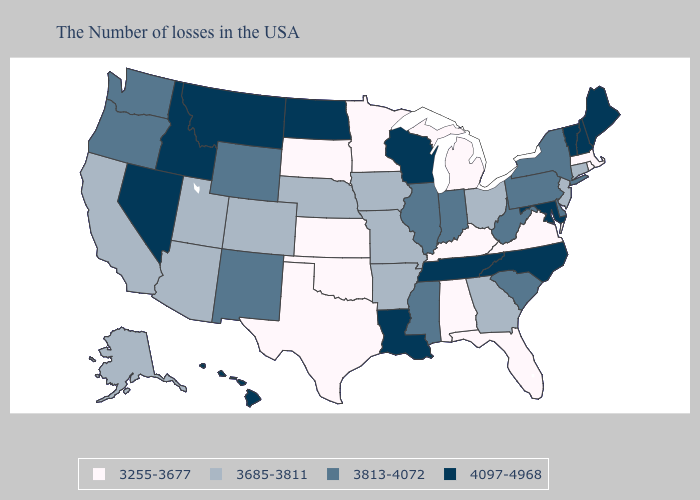What is the lowest value in the West?
Short answer required. 3685-3811. Does Arizona have the highest value in the West?
Write a very short answer. No. What is the highest value in the USA?
Short answer required. 4097-4968. What is the lowest value in the Northeast?
Give a very brief answer. 3255-3677. Name the states that have a value in the range 3813-4072?
Concise answer only. New York, Delaware, Pennsylvania, South Carolina, West Virginia, Indiana, Illinois, Mississippi, Wyoming, New Mexico, Washington, Oregon. What is the value of Wyoming?
Answer briefly. 3813-4072. Does Alaska have the lowest value in the West?
Concise answer only. Yes. What is the highest value in the Northeast ?
Give a very brief answer. 4097-4968. Name the states that have a value in the range 3255-3677?
Short answer required. Massachusetts, Rhode Island, Virginia, Florida, Michigan, Kentucky, Alabama, Minnesota, Kansas, Oklahoma, Texas, South Dakota. What is the value of Idaho?
Give a very brief answer. 4097-4968. Does Iowa have the highest value in the MidWest?
Be succinct. No. Name the states that have a value in the range 3255-3677?
Answer briefly. Massachusetts, Rhode Island, Virginia, Florida, Michigan, Kentucky, Alabama, Minnesota, Kansas, Oklahoma, Texas, South Dakota. Does Minnesota have the lowest value in the USA?
Give a very brief answer. Yes. What is the lowest value in the Northeast?
Quick response, please. 3255-3677. 